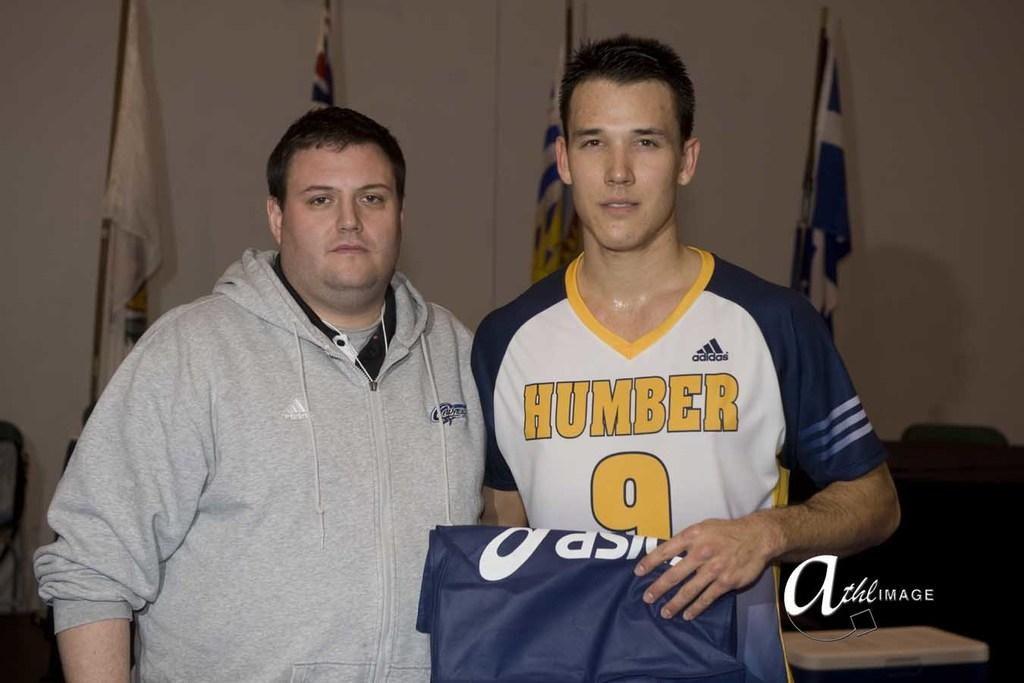<image>
Give a short and clear explanation of the subsequent image. A boy in a Humber jersey stands next to man in a grey hoodie 